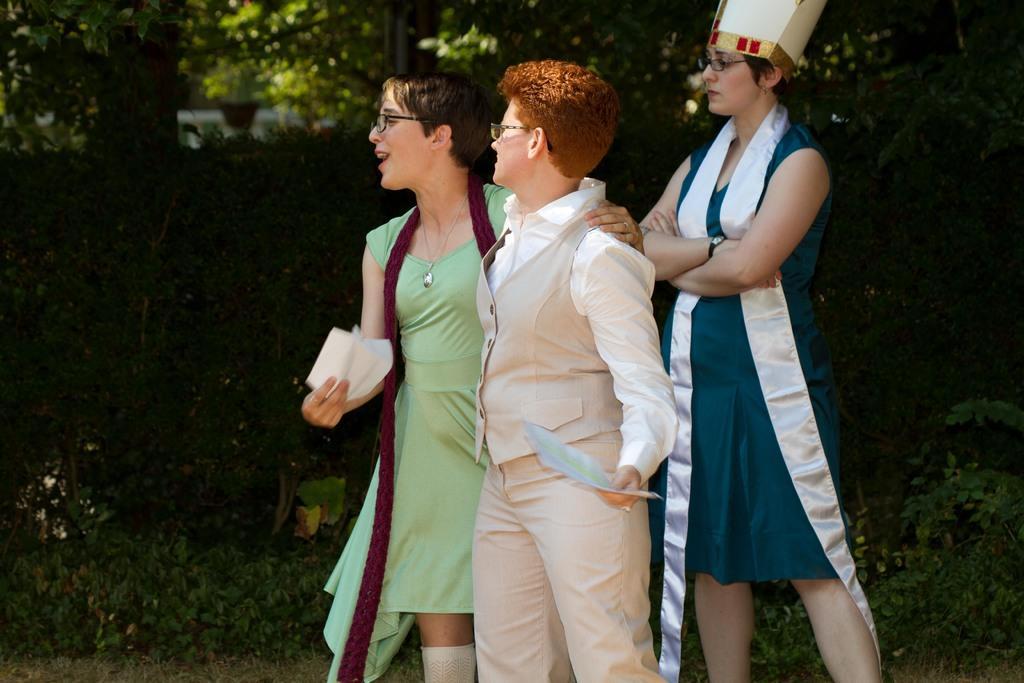In one or two sentences, can you explain what this image depicts? In this image we can see people standing on the ground. In the background there are shrubs, bushes and trees. 